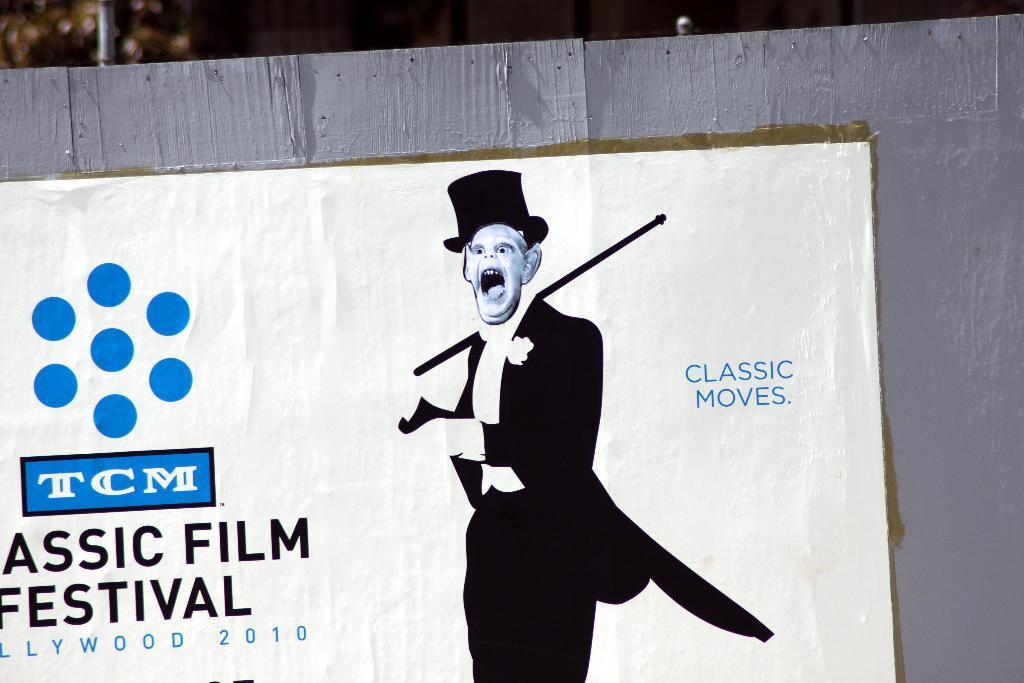Could you give a brief overview of what you see in this image? In this image in the foreground there is a board and on the board there is a poster with some text and images on it and the background is blurry. 